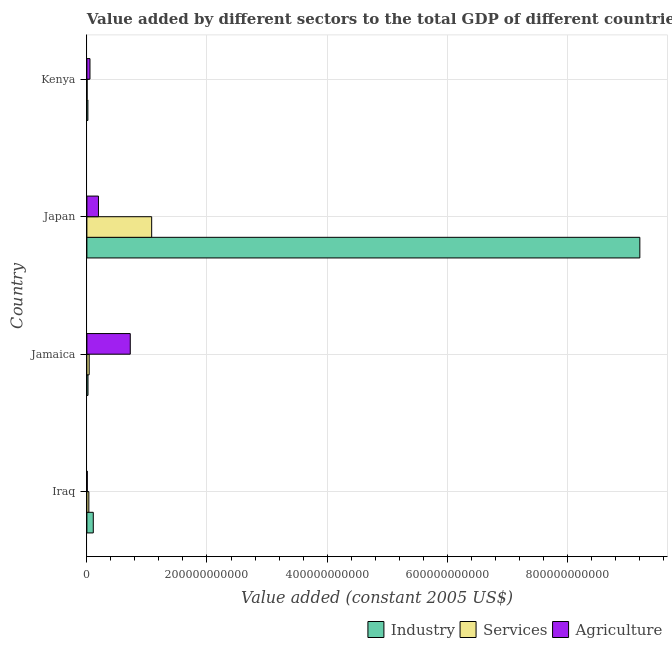How many different coloured bars are there?
Offer a very short reply. 3. What is the label of the 3rd group of bars from the top?
Ensure brevity in your answer.  Jamaica. What is the value added by industrial sector in Kenya?
Provide a short and direct response. 1.66e+09. Across all countries, what is the maximum value added by industrial sector?
Ensure brevity in your answer.  9.21e+11. Across all countries, what is the minimum value added by agricultural sector?
Your answer should be compact. 6.43e+08. In which country was the value added by industrial sector minimum?
Keep it short and to the point. Kenya. What is the total value added by agricultural sector in the graph?
Offer a very short reply. 9.73e+1. What is the difference between the value added by industrial sector in Iraq and that in Kenya?
Ensure brevity in your answer.  8.98e+09. What is the difference between the value added by services in Kenya and the value added by agricultural sector in Jamaica?
Provide a short and direct response. -7.19e+1. What is the average value added by services per country?
Make the answer very short. 2.88e+1. What is the difference between the value added by agricultural sector and value added by services in Kenya?
Ensure brevity in your answer.  4.81e+09. In how many countries, is the value added by industrial sector greater than 720000000000 US$?
Provide a succinct answer. 1. What is the ratio of the value added by agricultural sector in Japan to that in Kenya?
Your answer should be very brief. 3.75. What is the difference between the highest and the second highest value added by agricultural sector?
Keep it short and to the point. 5.30e+1. What is the difference between the highest and the lowest value added by services?
Give a very brief answer. 1.08e+11. What does the 2nd bar from the top in Iraq represents?
Your response must be concise. Services. What does the 3rd bar from the bottom in Kenya represents?
Give a very brief answer. Agriculture. Are all the bars in the graph horizontal?
Provide a short and direct response. Yes. What is the difference between two consecutive major ticks on the X-axis?
Your response must be concise. 2.00e+11. Are the values on the major ticks of X-axis written in scientific E-notation?
Provide a short and direct response. No. Does the graph contain any zero values?
Your answer should be compact. No. Where does the legend appear in the graph?
Keep it short and to the point. Bottom right. How many legend labels are there?
Ensure brevity in your answer.  3. What is the title of the graph?
Offer a terse response. Value added by different sectors to the total GDP of different countries. What is the label or title of the X-axis?
Keep it short and to the point. Value added (constant 2005 US$). What is the label or title of the Y-axis?
Offer a terse response. Country. What is the Value added (constant 2005 US$) of Industry in Iraq?
Offer a very short reply. 1.06e+1. What is the Value added (constant 2005 US$) in Services in Iraq?
Offer a terse response. 3.24e+09. What is the Value added (constant 2005 US$) in Agriculture in Iraq?
Your answer should be very brief. 6.43e+08. What is the Value added (constant 2005 US$) in Industry in Jamaica?
Your response must be concise. 1.85e+09. What is the Value added (constant 2005 US$) in Services in Jamaica?
Your answer should be compact. 3.80e+09. What is the Value added (constant 2005 US$) of Agriculture in Jamaica?
Ensure brevity in your answer.  7.22e+1. What is the Value added (constant 2005 US$) in Industry in Japan?
Your answer should be compact. 9.21e+11. What is the Value added (constant 2005 US$) in Services in Japan?
Your response must be concise. 1.08e+11. What is the Value added (constant 2005 US$) of Agriculture in Japan?
Your answer should be compact. 1.92e+1. What is the Value added (constant 2005 US$) of Industry in Kenya?
Ensure brevity in your answer.  1.66e+09. What is the Value added (constant 2005 US$) in Services in Kenya?
Your answer should be compact. 3.21e+08. What is the Value added (constant 2005 US$) of Agriculture in Kenya?
Make the answer very short. 5.13e+09. Across all countries, what is the maximum Value added (constant 2005 US$) of Industry?
Your answer should be compact. 9.21e+11. Across all countries, what is the maximum Value added (constant 2005 US$) of Services?
Ensure brevity in your answer.  1.08e+11. Across all countries, what is the maximum Value added (constant 2005 US$) in Agriculture?
Provide a short and direct response. 7.22e+1. Across all countries, what is the minimum Value added (constant 2005 US$) in Industry?
Offer a terse response. 1.66e+09. Across all countries, what is the minimum Value added (constant 2005 US$) of Services?
Offer a terse response. 3.21e+08. Across all countries, what is the minimum Value added (constant 2005 US$) of Agriculture?
Keep it short and to the point. 6.43e+08. What is the total Value added (constant 2005 US$) of Industry in the graph?
Ensure brevity in your answer.  9.35e+11. What is the total Value added (constant 2005 US$) of Services in the graph?
Provide a short and direct response. 1.15e+11. What is the total Value added (constant 2005 US$) of Agriculture in the graph?
Offer a terse response. 9.73e+1. What is the difference between the Value added (constant 2005 US$) of Industry in Iraq and that in Jamaica?
Provide a short and direct response. 8.78e+09. What is the difference between the Value added (constant 2005 US$) of Services in Iraq and that in Jamaica?
Your response must be concise. -5.63e+08. What is the difference between the Value added (constant 2005 US$) in Agriculture in Iraq and that in Jamaica?
Provide a succinct answer. -7.16e+1. What is the difference between the Value added (constant 2005 US$) of Industry in Iraq and that in Japan?
Offer a very short reply. -9.10e+11. What is the difference between the Value added (constant 2005 US$) in Services in Iraq and that in Japan?
Keep it short and to the point. -1.05e+11. What is the difference between the Value added (constant 2005 US$) in Agriculture in Iraq and that in Japan?
Provide a succinct answer. -1.86e+1. What is the difference between the Value added (constant 2005 US$) in Industry in Iraq and that in Kenya?
Make the answer very short. 8.98e+09. What is the difference between the Value added (constant 2005 US$) of Services in Iraq and that in Kenya?
Make the answer very short. 2.92e+09. What is the difference between the Value added (constant 2005 US$) of Agriculture in Iraq and that in Kenya?
Offer a terse response. -4.48e+09. What is the difference between the Value added (constant 2005 US$) of Industry in Jamaica and that in Japan?
Provide a succinct answer. -9.19e+11. What is the difference between the Value added (constant 2005 US$) of Services in Jamaica and that in Japan?
Keep it short and to the point. -1.04e+11. What is the difference between the Value added (constant 2005 US$) in Agriculture in Jamaica and that in Japan?
Your answer should be very brief. 5.30e+1. What is the difference between the Value added (constant 2005 US$) in Industry in Jamaica and that in Kenya?
Ensure brevity in your answer.  1.91e+08. What is the difference between the Value added (constant 2005 US$) in Services in Jamaica and that in Kenya?
Keep it short and to the point. 3.48e+09. What is the difference between the Value added (constant 2005 US$) in Agriculture in Jamaica and that in Kenya?
Your answer should be very brief. 6.71e+1. What is the difference between the Value added (constant 2005 US$) in Industry in Japan and that in Kenya?
Provide a short and direct response. 9.19e+11. What is the difference between the Value added (constant 2005 US$) in Services in Japan and that in Kenya?
Ensure brevity in your answer.  1.08e+11. What is the difference between the Value added (constant 2005 US$) in Agriculture in Japan and that in Kenya?
Keep it short and to the point. 1.41e+1. What is the difference between the Value added (constant 2005 US$) in Industry in Iraq and the Value added (constant 2005 US$) in Services in Jamaica?
Offer a very short reply. 6.83e+09. What is the difference between the Value added (constant 2005 US$) in Industry in Iraq and the Value added (constant 2005 US$) in Agriculture in Jamaica?
Give a very brief answer. -6.16e+1. What is the difference between the Value added (constant 2005 US$) of Services in Iraq and the Value added (constant 2005 US$) of Agriculture in Jamaica?
Offer a very short reply. -6.90e+1. What is the difference between the Value added (constant 2005 US$) in Industry in Iraq and the Value added (constant 2005 US$) in Services in Japan?
Your answer should be very brief. -9.72e+1. What is the difference between the Value added (constant 2005 US$) in Industry in Iraq and the Value added (constant 2005 US$) in Agriculture in Japan?
Offer a very short reply. -8.61e+09. What is the difference between the Value added (constant 2005 US$) of Services in Iraq and the Value added (constant 2005 US$) of Agriculture in Japan?
Make the answer very short. -1.60e+1. What is the difference between the Value added (constant 2005 US$) in Industry in Iraq and the Value added (constant 2005 US$) in Services in Kenya?
Your answer should be very brief. 1.03e+1. What is the difference between the Value added (constant 2005 US$) in Industry in Iraq and the Value added (constant 2005 US$) in Agriculture in Kenya?
Your answer should be compact. 5.51e+09. What is the difference between the Value added (constant 2005 US$) in Services in Iraq and the Value added (constant 2005 US$) in Agriculture in Kenya?
Your answer should be compact. -1.89e+09. What is the difference between the Value added (constant 2005 US$) in Industry in Jamaica and the Value added (constant 2005 US$) in Services in Japan?
Ensure brevity in your answer.  -1.06e+11. What is the difference between the Value added (constant 2005 US$) in Industry in Jamaica and the Value added (constant 2005 US$) in Agriculture in Japan?
Ensure brevity in your answer.  -1.74e+1. What is the difference between the Value added (constant 2005 US$) of Services in Jamaica and the Value added (constant 2005 US$) of Agriculture in Japan?
Offer a very short reply. -1.54e+1. What is the difference between the Value added (constant 2005 US$) of Industry in Jamaica and the Value added (constant 2005 US$) of Services in Kenya?
Keep it short and to the point. 1.53e+09. What is the difference between the Value added (constant 2005 US$) of Industry in Jamaica and the Value added (constant 2005 US$) of Agriculture in Kenya?
Your response must be concise. -3.28e+09. What is the difference between the Value added (constant 2005 US$) in Services in Jamaica and the Value added (constant 2005 US$) in Agriculture in Kenya?
Your answer should be compact. -1.32e+09. What is the difference between the Value added (constant 2005 US$) of Industry in Japan and the Value added (constant 2005 US$) of Services in Kenya?
Offer a very short reply. 9.21e+11. What is the difference between the Value added (constant 2005 US$) of Industry in Japan and the Value added (constant 2005 US$) of Agriculture in Kenya?
Your answer should be compact. 9.16e+11. What is the difference between the Value added (constant 2005 US$) of Services in Japan and the Value added (constant 2005 US$) of Agriculture in Kenya?
Keep it short and to the point. 1.03e+11. What is the average Value added (constant 2005 US$) in Industry per country?
Make the answer very short. 2.34e+11. What is the average Value added (constant 2005 US$) in Services per country?
Your answer should be very brief. 2.88e+1. What is the average Value added (constant 2005 US$) in Agriculture per country?
Make the answer very short. 2.43e+1. What is the difference between the Value added (constant 2005 US$) in Industry and Value added (constant 2005 US$) in Services in Iraq?
Keep it short and to the point. 7.39e+09. What is the difference between the Value added (constant 2005 US$) of Industry and Value added (constant 2005 US$) of Agriculture in Iraq?
Offer a very short reply. 9.99e+09. What is the difference between the Value added (constant 2005 US$) in Services and Value added (constant 2005 US$) in Agriculture in Iraq?
Provide a short and direct response. 2.60e+09. What is the difference between the Value added (constant 2005 US$) of Industry and Value added (constant 2005 US$) of Services in Jamaica?
Your answer should be compact. -1.95e+09. What is the difference between the Value added (constant 2005 US$) of Industry and Value added (constant 2005 US$) of Agriculture in Jamaica?
Keep it short and to the point. -7.04e+1. What is the difference between the Value added (constant 2005 US$) in Services and Value added (constant 2005 US$) in Agriculture in Jamaica?
Give a very brief answer. -6.84e+1. What is the difference between the Value added (constant 2005 US$) of Industry and Value added (constant 2005 US$) of Services in Japan?
Provide a succinct answer. 8.13e+11. What is the difference between the Value added (constant 2005 US$) in Industry and Value added (constant 2005 US$) in Agriculture in Japan?
Keep it short and to the point. 9.02e+11. What is the difference between the Value added (constant 2005 US$) of Services and Value added (constant 2005 US$) of Agriculture in Japan?
Provide a succinct answer. 8.86e+1. What is the difference between the Value added (constant 2005 US$) in Industry and Value added (constant 2005 US$) in Services in Kenya?
Give a very brief answer. 1.34e+09. What is the difference between the Value added (constant 2005 US$) in Industry and Value added (constant 2005 US$) in Agriculture in Kenya?
Give a very brief answer. -3.47e+09. What is the difference between the Value added (constant 2005 US$) in Services and Value added (constant 2005 US$) in Agriculture in Kenya?
Keep it short and to the point. -4.81e+09. What is the ratio of the Value added (constant 2005 US$) of Industry in Iraq to that in Jamaica?
Give a very brief answer. 5.74. What is the ratio of the Value added (constant 2005 US$) of Services in Iraq to that in Jamaica?
Offer a terse response. 0.85. What is the ratio of the Value added (constant 2005 US$) in Agriculture in Iraq to that in Jamaica?
Provide a short and direct response. 0.01. What is the ratio of the Value added (constant 2005 US$) in Industry in Iraq to that in Japan?
Give a very brief answer. 0.01. What is the ratio of the Value added (constant 2005 US$) in Services in Iraq to that in Japan?
Give a very brief answer. 0.03. What is the ratio of the Value added (constant 2005 US$) of Agriculture in Iraq to that in Japan?
Give a very brief answer. 0.03. What is the ratio of the Value added (constant 2005 US$) in Industry in Iraq to that in Kenya?
Make the answer very short. 6.41. What is the ratio of the Value added (constant 2005 US$) in Services in Iraq to that in Kenya?
Your answer should be compact. 10.09. What is the ratio of the Value added (constant 2005 US$) of Agriculture in Iraq to that in Kenya?
Keep it short and to the point. 0.13. What is the ratio of the Value added (constant 2005 US$) in Industry in Jamaica to that in Japan?
Your answer should be very brief. 0. What is the ratio of the Value added (constant 2005 US$) in Services in Jamaica to that in Japan?
Make the answer very short. 0.04. What is the ratio of the Value added (constant 2005 US$) of Agriculture in Jamaica to that in Japan?
Offer a very short reply. 3.75. What is the ratio of the Value added (constant 2005 US$) in Industry in Jamaica to that in Kenya?
Provide a short and direct response. 1.12. What is the ratio of the Value added (constant 2005 US$) in Services in Jamaica to that in Kenya?
Make the answer very short. 11.85. What is the ratio of the Value added (constant 2005 US$) of Agriculture in Jamaica to that in Kenya?
Provide a short and direct response. 14.09. What is the ratio of the Value added (constant 2005 US$) of Industry in Japan to that in Kenya?
Offer a very short reply. 554.56. What is the ratio of the Value added (constant 2005 US$) of Services in Japan to that in Kenya?
Offer a very short reply. 335.9. What is the ratio of the Value added (constant 2005 US$) of Agriculture in Japan to that in Kenya?
Your answer should be very brief. 3.75. What is the difference between the highest and the second highest Value added (constant 2005 US$) in Industry?
Offer a very short reply. 9.10e+11. What is the difference between the highest and the second highest Value added (constant 2005 US$) in Services?
Provide a short and direct response. 1.04e+11. What is the difference between the highest and the second highest Value added (constant 2005 US$) in Agriculture?
Provide a succinct answer. 5.30e+1. What is the difference between the highest and the lowest Value added (constant 2005 US$) of Industry?
Provide a short and direct response. 9.19e+11. What is the difference between the highest and the lowest Value added (constant 2005 US$) in Services?
Offer a terse response. 1.08e+11. What is the difference between the highest and the lowest Value added (constant 2005 US$) of Agriculture?
Offer a terse response. 7.16e+1. 